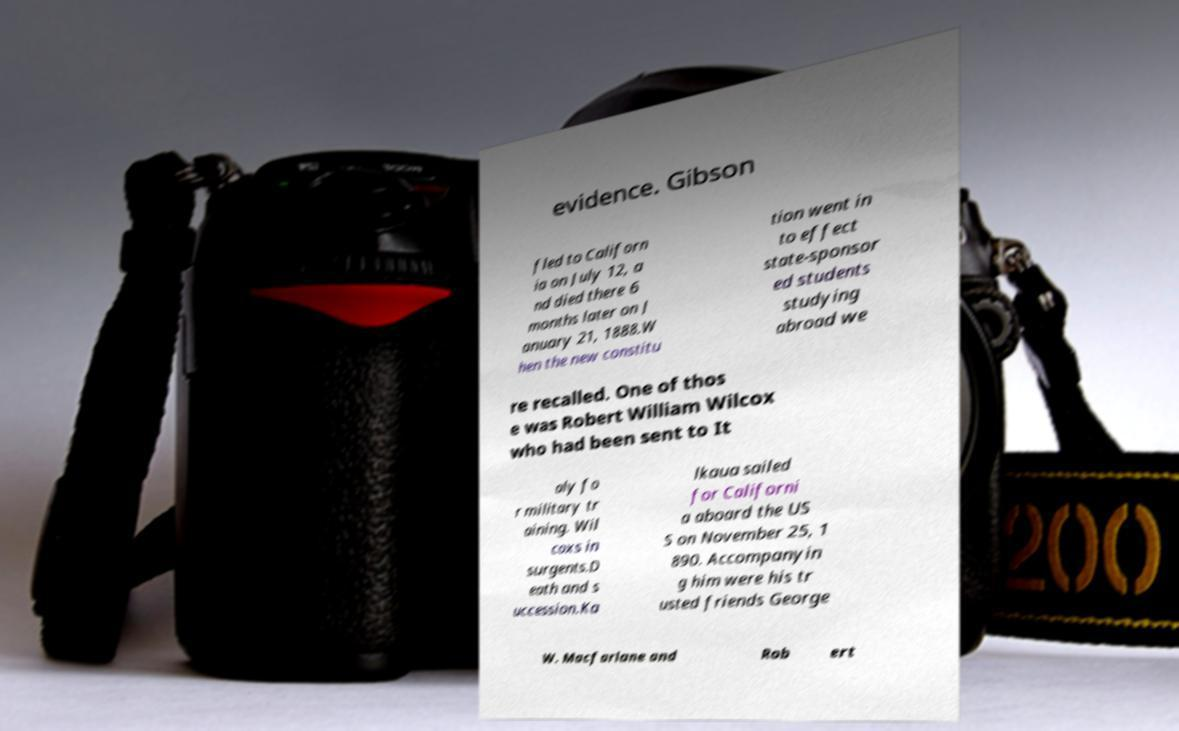There's text embedded in this image that I need extracted. Can you transcribe it verbatim? evidence. Gibson fled to Californ ia on July 12, a nd died there 6 months later on J anuary 21, 1888.W hen the new constitu tion went in to effect state-sponsor ed students studying abroad we re recalled. One of thos e was Robert William Wilcox who had been sent to It aly fo r military tr aining. Wil coxs in surgents.D eath and s uccession.Ka lkaua sailed for Californi a aboard the US S on November 25, 1 890. Accompanyin g him were his tr usted friends George W. Macfarlane and Rob ert 